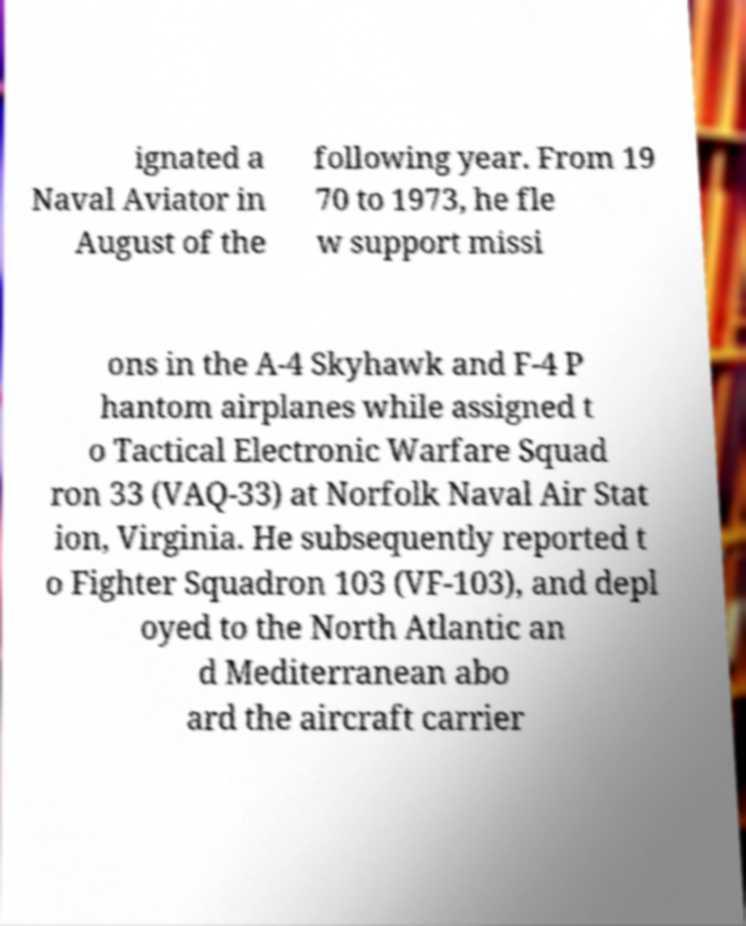Could you extract and type out the text from this image? ignated a Naval Aviator in August of the following year. From 19 70 to 1973, he fle w support missi ons in the A-4 Skyhawk and F-4 P hantom airplanes while assigned t o Tactical Electronic Warfare Squad ron 33 (VAQ-33) at Norfolk Naval Air Stat ion, Virginia. He subsequently reported t o Fighter Squadron 103 (VF-103), and depl oyed to the North Atlantic an d Mediterranean abo ard the aircraft carrier 